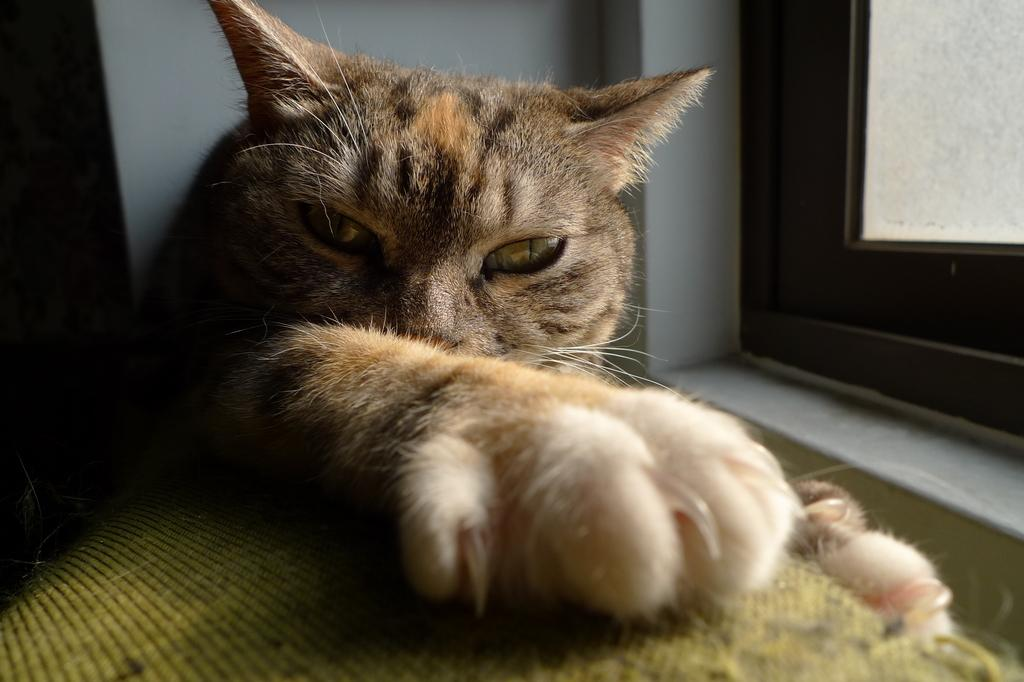What type of animal can be seen in the image? There is a cat in the image. What color is the cloth at the bottom of the image? The cloth at the bottom of the image is yellow. What can be seen in the background of the image? There is a wall in the background of the image. Where is the window located in the image? The window is on the right side of the image. What type of hair can be seen on the cat's head in the image? There is no hair visible on the cat's head in the image; it is a cat, which has fur, not hair. What type of pan is being used to cook the chicken in the image? There is no pan or chicken present in the image; it only features a cat, a yellow cloth, a wall, and a window. 